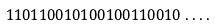Convert formula to latex. <formula><loc_0><loc_0><loc_500><loc_500>1 1 0 1 1 0 0 1 0 1 0 0 1 0 0 1 1 0 0 1 0 \dots .</formula> 